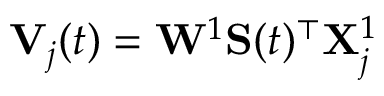<formula> <loc_0><loc_0><loc_500><loc_500>V _ { j } ( t ) = W ^ { 1 } S ( t ) ^ { \top } X _ { j } ^ { 1 }</formula> 